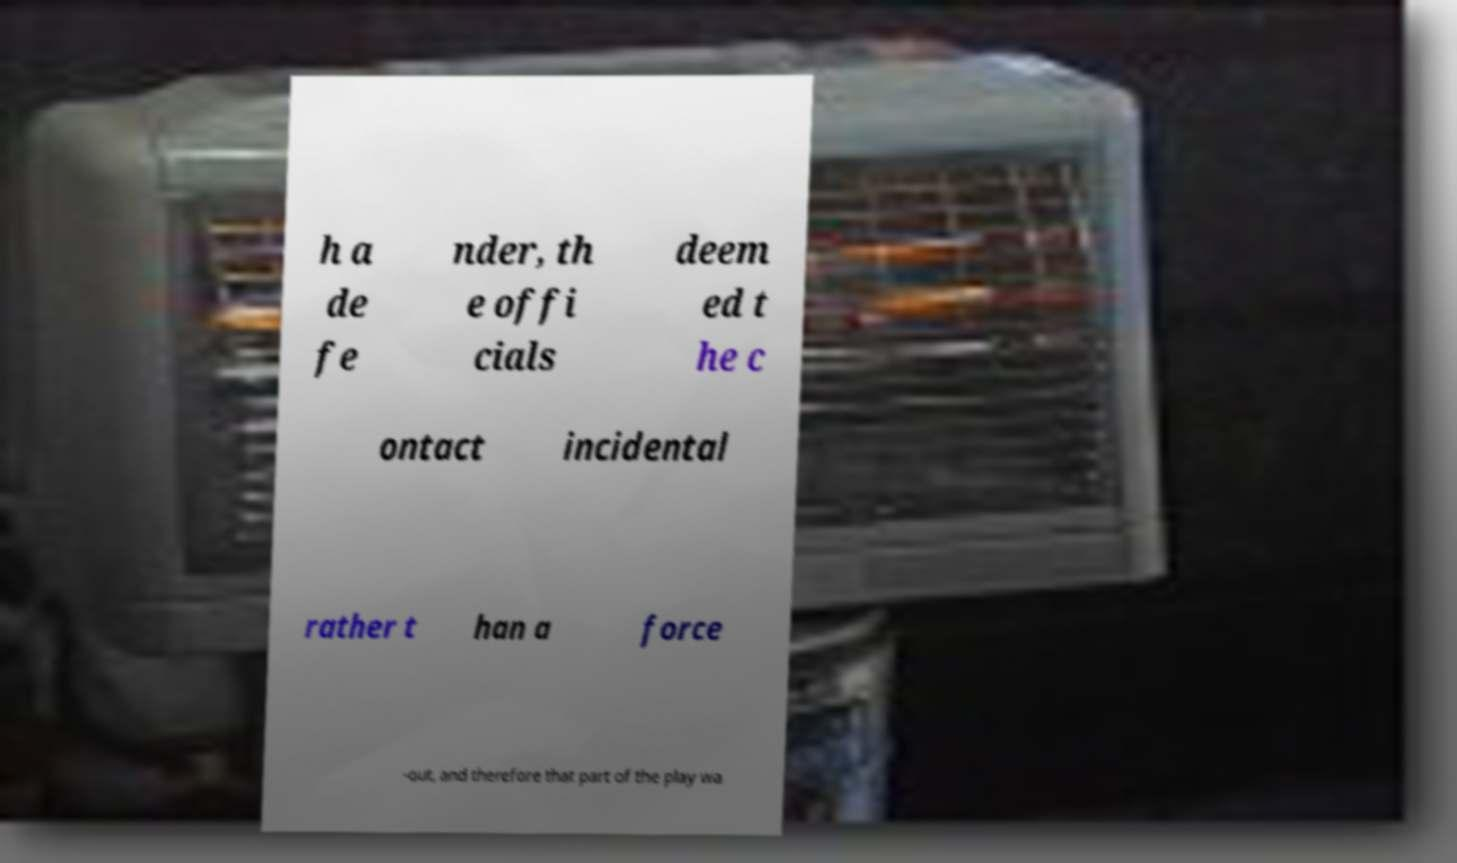Please identify and transcribe the text found in this image. h a de fe nder, th e offi cials deem ed t he c ontact incidental rather t han a force -out, and therefore that part of the play wa 